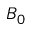Convert formula to latex. <formula><loc_0><loc_0><loc_500><loc_500>B _ { 0 }</formula> 